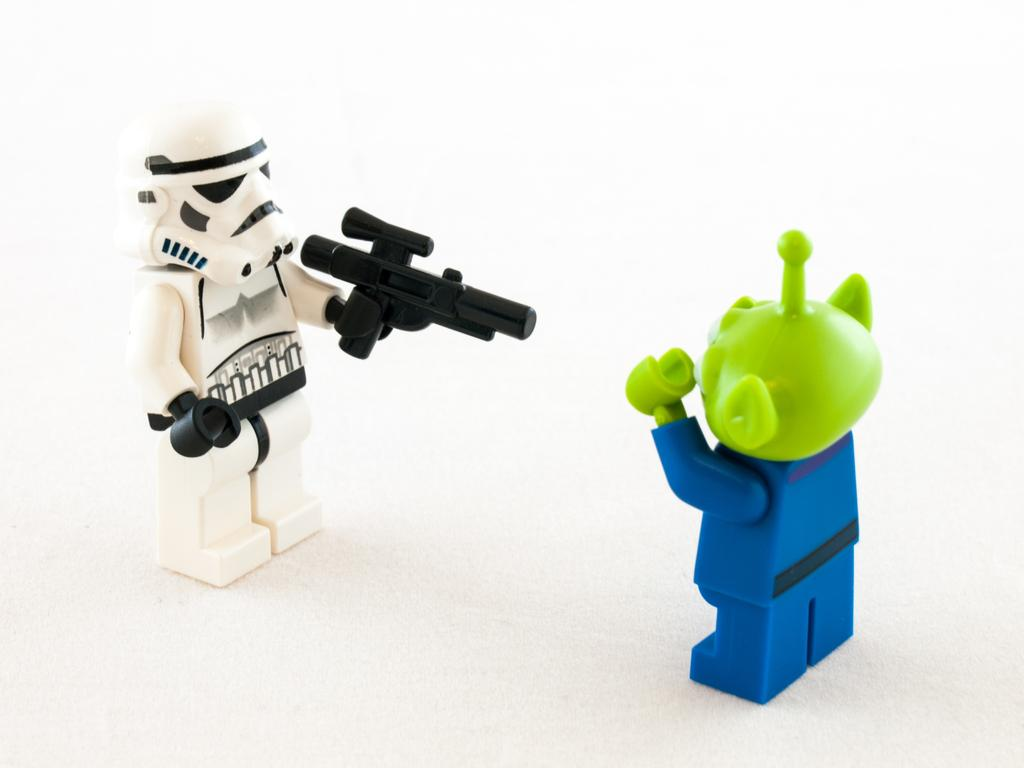How many toys are present in the image? There are two toys in the image. What colors can be seen on the toys? The toys have white, black, green, and blue colors. What is the color of the background in the image? The background of the image is white. What day of the week is depicted in the image? There is no day of the week depicted in the image; it only features two toys and a white background. Can you describe the digestion process of the toys in the image? The toys in the image are inanimate objects and do not have a digestion process. 